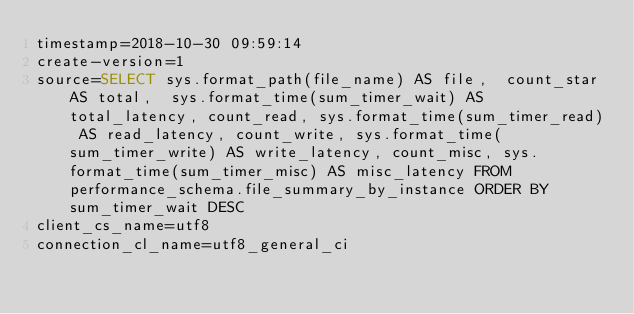Convert code to text. <code><loc_0><loc_0><loc_500><loc_500><_VisualBasic_>timestamp=2018-10-30 09:59:14
create-version=1
source=SELECT sys.format_path(file_name) AS file,  count_star AS total,  sys.format_time(sum_timer_wait) AS total_latency, count_read, sys.format_time(sum_timer_read) AS read_latency, count_write, sys.format_time(sum_timer_write) AS write_latency, count_misc, sys.format_time(sum_timer_misc) AS misc_latency FROM performance_schema.file_summary_by_instance ORDER BY sum_timer_wait DESC
client_cs_name=utf8
connection_cl_name=utf8_general_ci</code> 